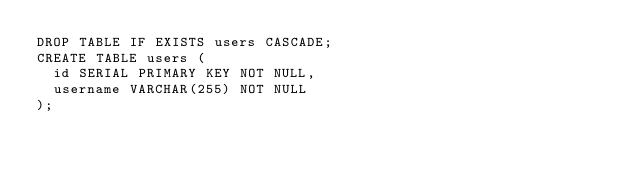Convert code to text. <code><loc_0><loc_0><loc_500><loc_500><_SQL_>DROP TABLE IF EXISTS users CASCADE;
CREATE TABLE users (
  id SERIAL PRIMARY KEY NOT NULL,
  username VARCHAR(255) NOT NULL
);

</code> 